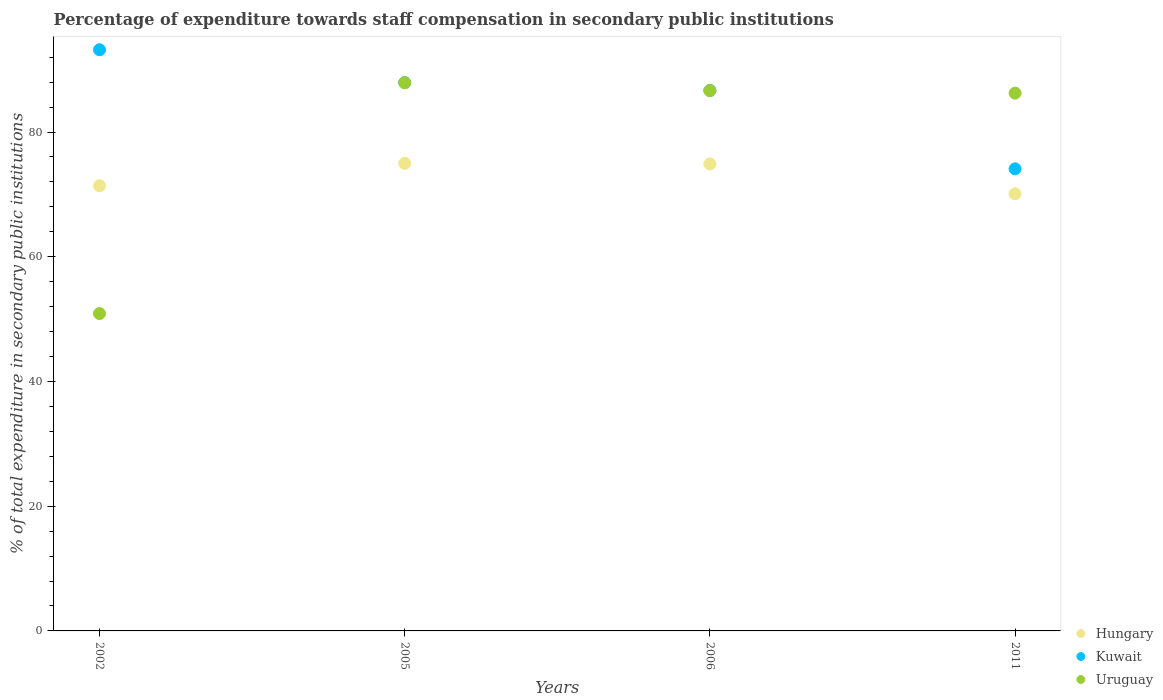How many different coloured dotlines are there?
Your answer should be very brief. 3. Is the number of dotlines equal to the number of legend labels?
Provide a succinct answer. Yes. What is the percentage of expenditure towards staff compensation in Kuwait in 2005?
Your answer should be compact. 87.93. Across all years, what is the maximum percentage of expenditure towards staff compensation in Kuwait?
Give a very brief answer. 93.19. Across all years, what is the minimum percentage of expenditure towards staff compensation in Uruguay?
Keep it short and to the point. 50.89. What is the total percentage of expenditure towards staff compensation in Hungary in the graph?
Your answer should be very brief. 291.35. What is the difference between the percentage of expenditure towards staff compensation in Uruguay in 2002 and that in 2006?
Make the answer very short. -35.76. What is the difference between the percentage of expenditure towards staff compensation in Kuwait in 2006 and the percentage of expenditure towards staff compensation in Hungary in 2002?
Offer a terse response. 15.28. What is the average percentage of expenditure towards staff compensation in Kuwait per year?
Give a very brief answer. 85.47. In the year 2006, what is the difference between the percentage of expenditure towards staff compensation in Kuwait and percentage of expenditure towards staff compensation in Uruguay?
Ensure brevity in your answer.  0.01. In how many years, is the percentage of expenditure towards staff compensation in Kuwait greater than 52 %?
Provide a succinct answer. 4. What is the ratio of the percentage of expenditure towards staff compensation in Uruguay in 2002 to that in 2006?
Ensure brevity in your answer.  0.59. What is the difference between the highest and the second highest percentage of expenditure towards staff compensation in Uruguay?
Give a very brief answer. 1.26. What is the difference between the highest and the lowest percentage of expenditure towards staff compensation in Kuwait?
Your response must be concise. 19.1. Is the sum of the percentage of expenditure towards staff compensation in Kuwait in 2005 and 2011 greater than the maximum percentage of expenditure towards staff compensation in Uruguay across all years?
Provide a short and direct response. Yes. Does the percentage of expenditure towards staff compensation in Uruguay monotonically increase over the years?
Ensure brevity in your answer.  No. Is the percentage of expenditure towards staff compensation in Uruguay strictly less than the percentage of expenditure towards staff compensation in Hungary over the years?
Your answer should be very brief. No. How many dotlines are there?
Your answer should be compact. 3. How many years are there in the graph?
Ensure brevity in your answer.  4. What is the difference between two consecutive major ticks on the Y-axis?
Keep it short and to the point. 20. Does the graph contain grids?
Your answer should be compact. No. Where does the legend appear in the graph?
Make the answer very short. Bottom right. How many legend labels are there?
Offer a terse response. 3. What is the title of the graph?
Offer a very short reply. Percentage of expenditure towards staff compensation in secondary public institutions. Does "Kenya" appear as one of the legend labels in the graph?
Offer a terse response. No. What is the label or title of the X-axis?
Provide a short and direct response. Years. What is the label or title of the Y-axis?
Offer a terse response. % of total expenditure in secondary public institutions. What is the % of total expenditure in secondary public institutions in Hungary in 2002?
Offer a terse response. 71.38. What is the % of total expenditure in secondary public institutions of Kuwait in 2002?
Keep it short and to the point. 93.19. What is the % of total expenditure in secondary public institutions in Uruguay in 2002?
Your response must be concise. 50.89. What is the % of total expenditure in secondary public institutions in Hungary in 2005?
Ensure brevity in your answer.  74.98. What is the % of total expenditure in secondary public institutions of Kuwait in 2005?
Provide a succinct answer. 87.93. What is the % of total expenditure in secondary public institutions of Uruguay in 2005?
Offer a very short reply. 87.9. What is the % of total expenditure in secondary public institutions of Hungary in 2006?
Your answer should be compact. 74.89. What is the % of total expenditure in secondary public institutions of Kuwait in 2006?
Provide a short and direct response. 86.66. What is the % of total expenditure in secondary public institutions of Uruguay in 2006?
Provide a succinct answer. 86.65. What is the % of total expenditure in secondary public institutions of Hungary in 2011?
Offer a terse response. 70.1. What is the % of total expenditure in secondary public institutions in Kuwait in 2011?
Ensure brevity in your answer.  74.09. What is the % of total expenditure in secondary public institutions in Uruguay in 2011?
Your response must be concise. 86.23. Across all years, what is the maximum % of total expenditure in secondary public institutions in Hungary?
Keep it short and to the point. 74.98. Across all years, what is the maximum % of total expenditure in secondary public institutions of Kuwait?
Provide a succinct answer. 93.19. Across all years, what is the maximum % of total expenditure in secondary public institutions in Uruguay?
Keep it short and to the point. 87.9. Across all years, what is the minimum % of total expenditure in secondary public institutions of Hungary?
Offer a very short reply. 70.1. Across all years, what is the minimum % of total expenditure in secondary public institutions of Kuwait?
Your response must be concise. 74.09. Across all years, what is the minimum % of total expenditure in secondary public institutions in Uruguay?
Provide a short and direct response. 50.89. What is the total % of total expenditure in secondary public institutions of Hungary in the graph?
Offer a very short reply. 291.35. What is the total % of total expenditure in secondary public institutions in Kuwait in the graph?
Offer a terse response. 341.87. What is the total % of total expenditure in secondary public institutions of Uruguay in the graph?
Offer a terse response. 311.68. What is the difference between the % of total expenditure in secondary public institutions in Hungary in 2002 and that in 2005?
Provide a short and direct response. -3.6. What is the difference between the % of total expenditure in secondary public institutions of Kuwait in 2002 and that in 2005?
Ensure brevity in your answer.  5.26. What is the difference between the % of total expenditure in secondary public institutions of Uruguay in 2002 and that in 2005?
Ensure brevity in your answer.  -37.01. What is the difference between the % of total expenditure in secondary public institutions of Hungary in 2002 and that in 2006?
Ensure brevity in your answer.  -3.51. What is the difference between the % of total expenditure in secondary public institutions in Kuwait in 2002 and that in 2006?
Keep it short and to the point. 6.53. What is the difference between the % of total expenditure in secondary public institutions in Uruguay in 2002 and that in 2006?
Offer a terse response. -35.76. What is the difference between the % of total expenditure in secondary public institutions of Hungary in 2002 and that in 2011?
Give a very brief answer. 1.28. What is the difference between the % of total expenditure in secondary public institutions of Kuwait in 2002 and that in 2011?
Provide a succinct answer. 19.1. What is the difference between the % of total expenditure in secondary public institutions of Uruguay in 2002 and that in 2011?
Offer a very short reply. -35.34. What is the difference between the % of total expenditure in secondary public institutions of Hungary in 2005 and that in 2006?
Make the answer very short. 0.09. What is the difference between the % of total expenditure in secondary public institutions in Kuwait in 2005 and that in 2006?
Your response must be concise. 1.27. What is the difference between the % of total expenditure in secondary public institutions in Uruguay in 2005 and that in 2006?
Offer a terse response. 1.26. What is the difference between the % of total expenditure in secondary public institutions of Hungary in 2005 and that in 2011?
Your answer should be very brief. 4.88. What is the difference between the % of total expenditure in secondary public institutions of Kuwait in 2005 and that in 2011?
Your answer should be compact. 13.83. What is the difference between the % of total expenditure in secondary public institutions of Uruguay in 2005 and that in 2011?
Offer a very short reply. 1.67. What is the difference between the % of total expenditure in secondary public institutions in Hungary in 2006 and that in 2011?
Give a very brief answer. 4.79. What is the difference between the % of total expenditure in secondary public institutions of Kuwait in 2006 and that in 2011?
Your response must be concise. 12.57. What is the difference between the % of total expenditure in secondary public institutions of Uruguay in 2006 and that in 2011?
Your answer should be very brief. 0.41. What is the difference between the % of total expenditure in secondary public institutions in Hungary in 2002 and the % of total expenditure in secondary public institutions in Kuwait in 2005?
Ensure brevity in your answer.  -16.55. What is the difference between the % of total expenditure in secondary public institutions of Hungary in 2002 and the % of total expenditure in secondary public institutions of Uruguay in 2005?
Keep it short and to the point. -16.52. What is the difference between the % of total expenditure in secondary public institutions in Kuwait in 2002 and the % of total expenditure in secondary public institutions in Uruguay in 2005?
Ensure brevity in your answer.  5.29. What is the difference between the % of total expenditure in secondary public institutions in Hungary in 2002 and the % of total expenditure in secondary public institutions in Kuwait in 2006?
Offer a very short reply. -15.28. What is the difference between the % of total expenditure in secondary public institutions of Hungary in 2002 and the % of total expenditure in secondary public institutions of Uruguay in 2006?
Ensure brevity in your answer.  -15.27. What is the difference between the % of total expenditure in secondary public institutions of Kuwait in 2002 and the % of total expenditure in secondary public institutions of Uruguay in 2006?
Your answer should be very brief. 6.54. What is the difference between the % of total expenditure in secondary public institutions of Hungary in 2002 and the % of total expenditure in secondary public institutions of Kuwait in 2011?
Provide a succinct answer. -2.71. What is the difference between the % of total expenditure in secondary public institutions in Hungary in 2002 and the % of total expenditure in secondary public institutions in Uruguay in 2011?
Give a very brief answer. -14.86. What is the difference between the % of total expenditure in secondary public institutions of Kuwait in 2002 and the % of total expenditure in secondary public institutions of Uruguay in 2011?
Offer a terse response. 6.96. What is the difference between the % of total expenditure in secondary public institutions of Hungary in 2005 and the % of total expenditure in secondary public institutions of Kuwait in 2006?
Provide a succinct answer. -11.68. What is the difference between the % of total expenditure in secondary public institutions of Hungary in 2005 and the % of total expenditure in secondary public institutions of Uruguay in 2006?
Provide a succinct answer. -11.67. What is the difference between the % of total expenditure in secondary public institutions in Kuwait in 2005 and the % of total expenditure in secondary public institutions in Uruguay in 2006?
Your answer should be very brief. 1.28. What is the difference between the % of total expenditure in secondary public institutions in Hungary in 2005 and the % of total expenditure in secondary public institutions in Kuwait in 2011?
Your answer should be compact. 0.88. What is the difference between the % of total expenditure in secondary public institutions of Hungary in 2005 and the % of total expenditure in secondary public institutions of Uruguay in 2011?
Ensure brevity in your answer.  -11.26. What is the difference between the % of total expenditure in secondary public institutions of Kuwait in 2005 and the % of total expenditure in secondary public institutions of Uruguay in 2011?
Ensure brevity in your answer.  1.69. What is the difference between the % of total expenditure in secondary public institutions in Hungary in 2006 and the % of total expenditure in secondary public institutions in Kuwait in 2011?
Your answer should be compact. 0.79. What is the difference between the % of total expenditure in secondary public institutions in Hungary in 2006 and the % of total expenditure in secondary public institutions in Uruguay in 2011?
Your response must be concise. -11.35. What is the difference between the % of total expenditure in secondary public institutions in Kuwait in 2006 and the % of total expenditure in secondary public institutions in Uruguay in 2011?
Provide a short and direct response. 0.43. What is the average % of total expenditure in secondary public institutions of Hungary per year?
Make the answer very short. 72.84. What is the average % of total expenditure in secondary public institutions in Kuwait per year?
Give a very brief answer. 85.47. What is the average % of total expenditure in secondary public institutions in Uruguay per year?
Give a very brief answer. 77.92. In the year 2002, what is the difference between the % of total expenditure in secondary public institutions in Hungary and % of total expenditure in secondary public institutions in Kuwait?
Offer a terse response. -21.81. In the year 2002, what is the difference between the % of total expenditure in secondary public institutions of Hungary and % of total expenditure in secondary public institutions of Uruguay?
Provide a short and direct response. 20.49. In the year 2002, what is the difference between the % of total expenditure in secondary public institutions in Kuwait and % of total expenditure in secondary public institutions in Uruguay?
Ensure brevity in your answer.  42.3. In the year 2005, what is the difference between the % of total expenditure in secondary public institutions of Hungary and % of total expenditure in secondary public institutions of Kuwait?
Provide a succinct answer. -12.95. In the year 2005, what is the difference between the % of total expenditure in secondary public institutions of Hungary and % of total expenditure in secondary public institutions of Uruguay?
Provide a short and direct response. -12.93. In the year 2005, what is the difference between the % of total expenditure in secondary public institutions in Kuwait and % of total expenditure in secondary public institutions in Uruguay?
Offer a very short reply. 0.02. In the year 2006, what is the difference between the % of total expenditure in secondary public institutions of Hungary and % of total expenditure in secondary public institutions of Kuwait?
Provide a short and direct response. -11.77. In the year 2006, what is the difference between the % of total expenditure in secondary public institutions of Hungary and % of total expenditure in secondary public institutions of Uruguay?
Give a very brief answer. -11.76. In the year 2006, what is the difference between the % of total expenditure in secondary public institutions of Kuwait and % of total expenditure in secondary public institutions of Uruguay?
Your answer should be compact. 0.01. In the year 2011, what is the difference between the % of total expenditure in secondary public institutions in Hungary and % of total expenditure in secondary public institutions in Kuwait?
Ensure brevity in your answer.  -4. In the year 2011, what is the difference between the % of total expenditure in secondary public institutions in Hungary and % of total expenditure in secondary public institutions in Uruguay?
Provide a succinct answer. -16.14. In the year 2011, what is the difference between the % of total expenditure in secondary public institutions of Kuwait and % of total expenditure in secondary public institutions of Uruguay?
Provide a succinct answer. -12.14. What is the ratio of the % of total expenditure in secondary public institutions of Kuwait in 2002 to that in 2005?
Your answer should be compact. 1.06. What is the ratio of the % of total expenditure in secondary public institutions of Uruguay in 2002 to that in 2005?
Your answer should be compact. 0.58. What is the ratio of the % of total expenditure in secondary public institutions in Hungary in 2002 to that in 2006?
Ensure brevity in your answer.  0.95. What is the ratio of the % of total expenditure in secondary public institutions of Kuwait in 2002 to that in 2006?
Keep it short and to the point. 1.08. What is the ratio of the % of total expenditure in secondary public institutions of Uruguay in 2002 to that in 2006?
Offer a very short reply. 0.59. What is the ratio of the % of total expenditure in secondary public institutions of Hungary in 2002 to that in 2011?
Your answer should be compact. 1.02. What is the ratio of the % of total expenditure in secondary public institutions of Kuwait in 2002 to that in 2011?
Offer a terse response. 1.26. What is the ratio of the % of total expenditure in secondary public institutions in Uruguay in 2002 to that in 2011?
Ensure brevity in your answer.  0.59. What is the ratio of the % of total expenditure in secondary public institutions in Hungary in 2005 to that in 2006?
Ensure brevity in your answer.  1. What is the ratio of the % of total expenditure in secondary public institutions of Kuwait in 2005 to that in 2006?
Provide a succinct answer. 1.01. What is the ratio of the % of total expenditure in secondary public institutions in Uruguay in 2005 to that in 2006?
Your answer should be very brief. 1.01. What is the ratio of the % of total expenditure in secondary public institutions in Hungary in 2005 to that in 2011?
Your answer should be compact. 1.07. What is the ratio of the % of total expenditure in secondary public institutions of Kuwait in 2005 to that in 2011?
Offer a terse response. 1.19. What is the ratio of the % of total expenditure in secondary public institutions of Uruguay in 2005 to that in 2011?
Provide a short and direct response. 1.02. What is the ratio of the % of total expenditure in secondary public institutions in Hungary in 2006 to that in 2011?
Give a very brief answer. 1.07. What is the ratio of the % of total expenditure in secondary public institutions in Kuwait in 2006 to that in 2011?
Your answer should be very brief. 1.17. What is the difference between the highest and the second highest % of total expenditure in secondary public institutions in Hungary?
Give a very brief answer. 0.09. What is the difference between the highest and the second highest % of total expenditure in secondary public institutions in Kuwait?
Ensure brevity in your answer.  5.26. What is the difference between the highest and the second highest % of total expenditure in secondary public institutions of Uruguay?
Keep it short and to the point. 1.26. What is the difference between the highest and the lowest % of total expenditure in secondary public institutions of Hungary?
Your answer should be compact. 4.88. What is the difference between the highest and the lowest % of total expenditure in secondary public institutions in Kuwait?
Your answer should be very brief. 19.1. What is the difference between the highest and the lowest % of total expenditure in secondary public institutions of Uruguay?
Provide a short and direct response. 37.01. 